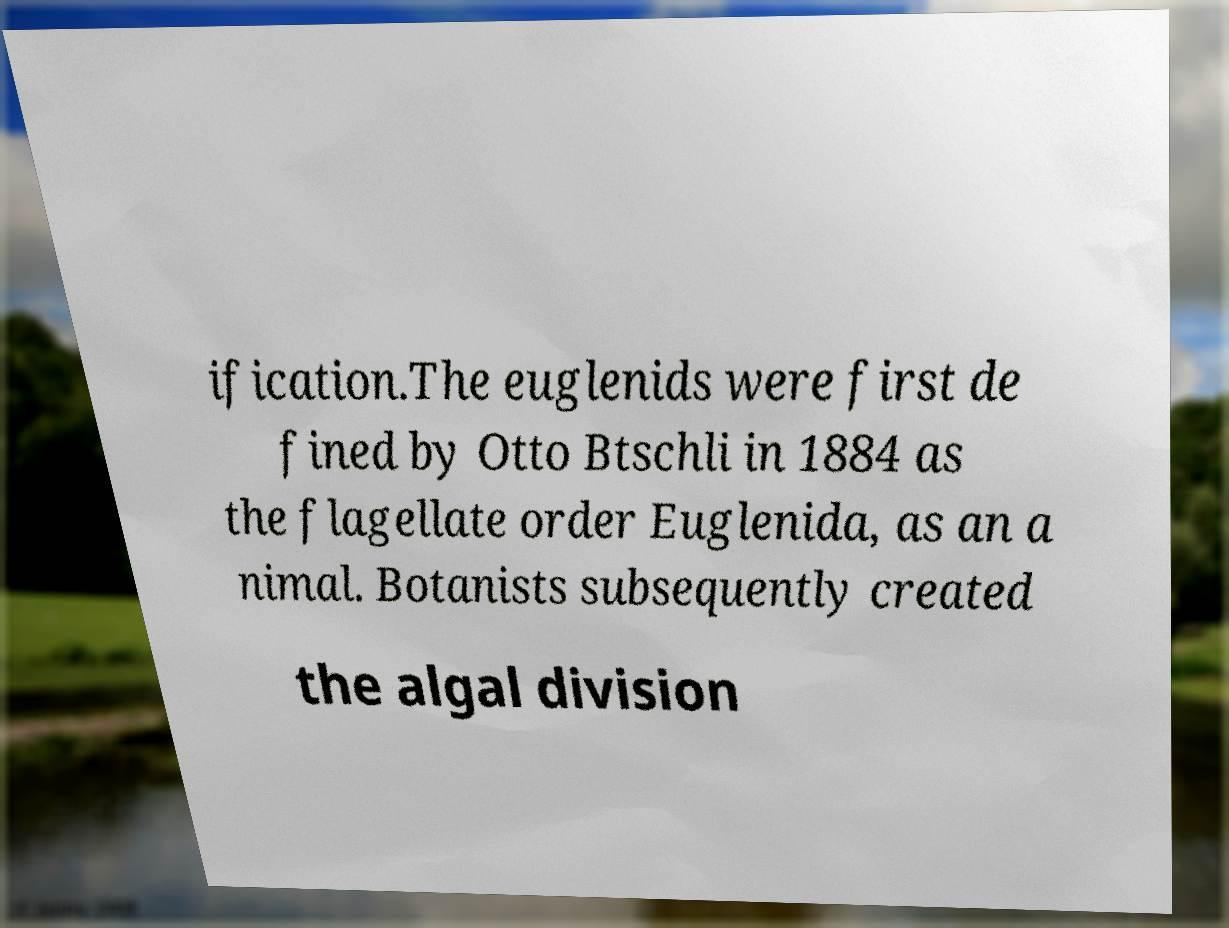What messages or text are displayed in this image? I need them in a readable, typed format. ification.The euglenids were first de fined by Otto Btschli in 1884 as the flagellate order Euglenida, as an a nimal. Botanists subsequently created the algal division 